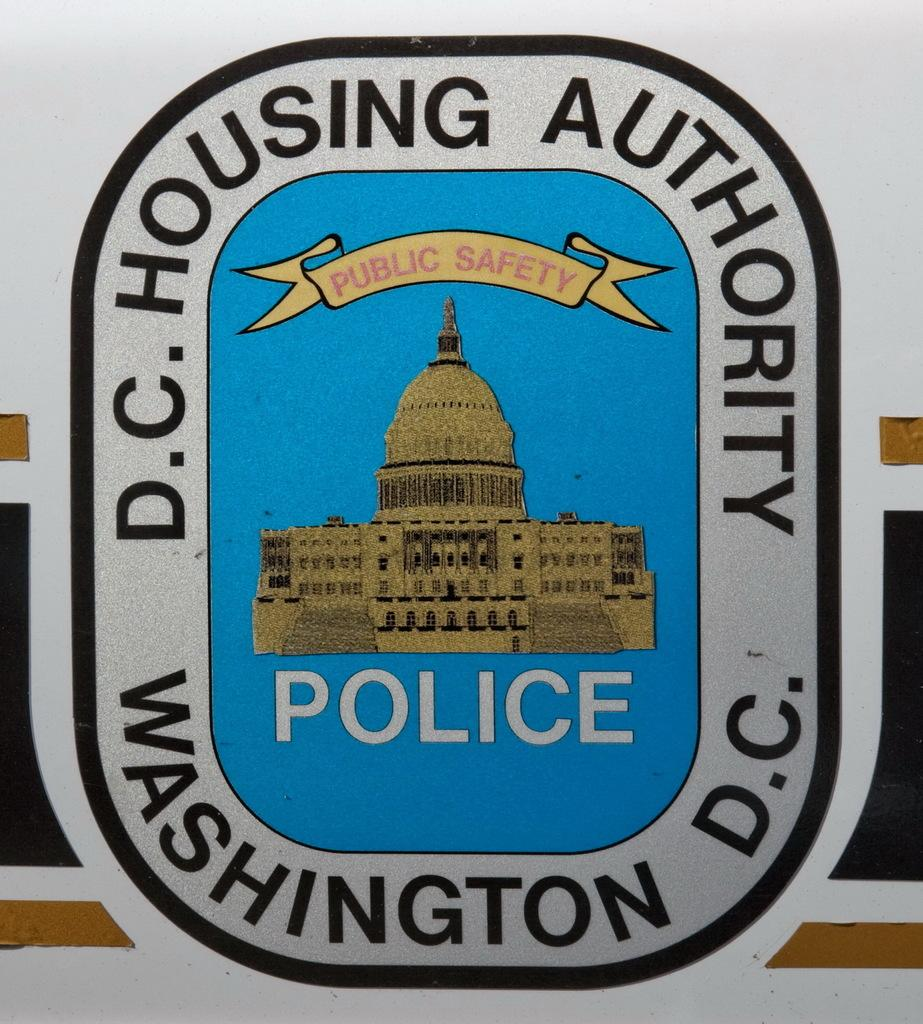<image>
Share a concise interpretation of the image provided. A sticker that is for the D.C. Housing Authority Police in Washington D.C. 